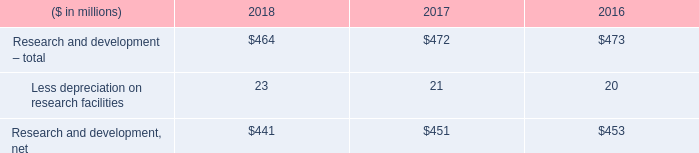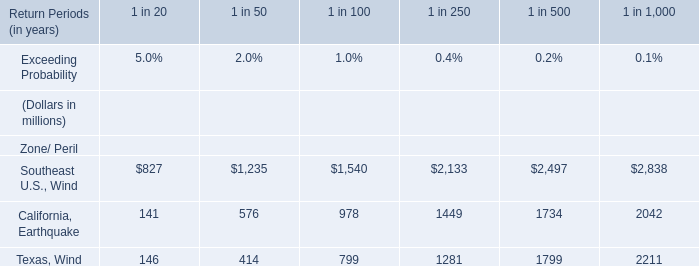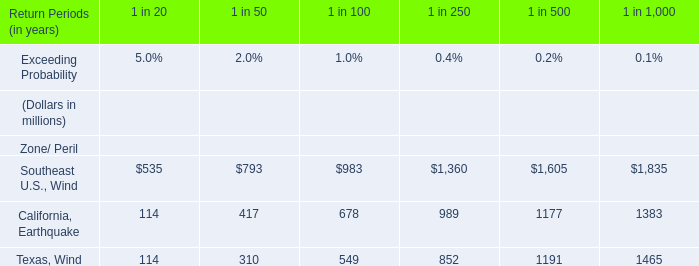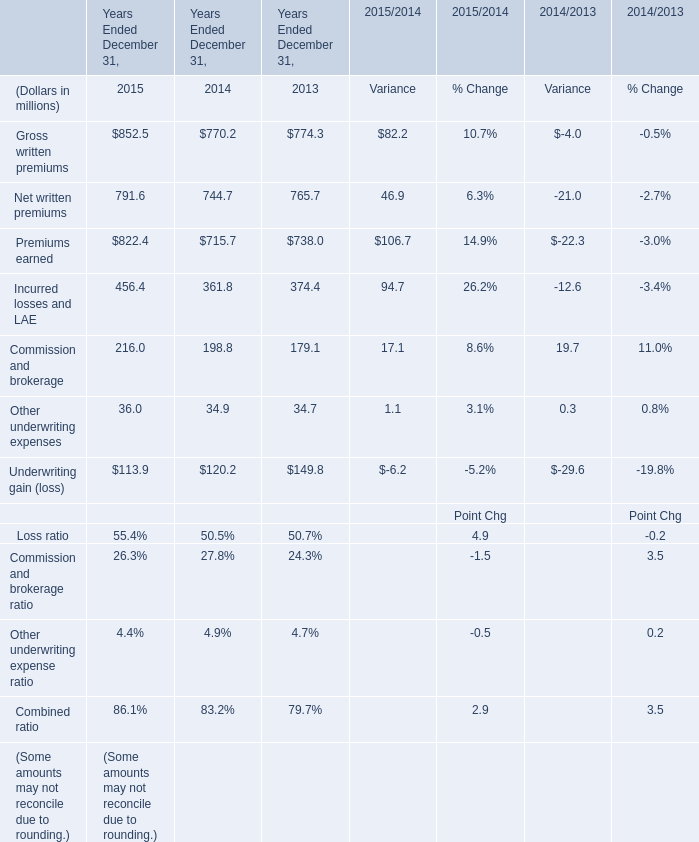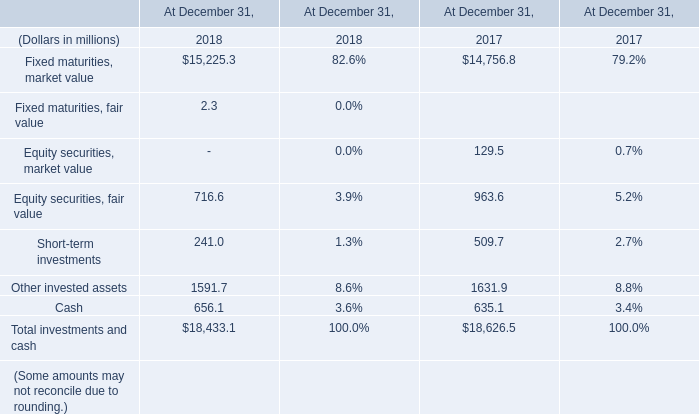What do all Years Ended December 31 sum up without those Years Ended December 31 smaller than 400, in 2014? (in million) 
Computations: ((770.2 + 744.7) + 715.7)
Answer: 2230.6. 